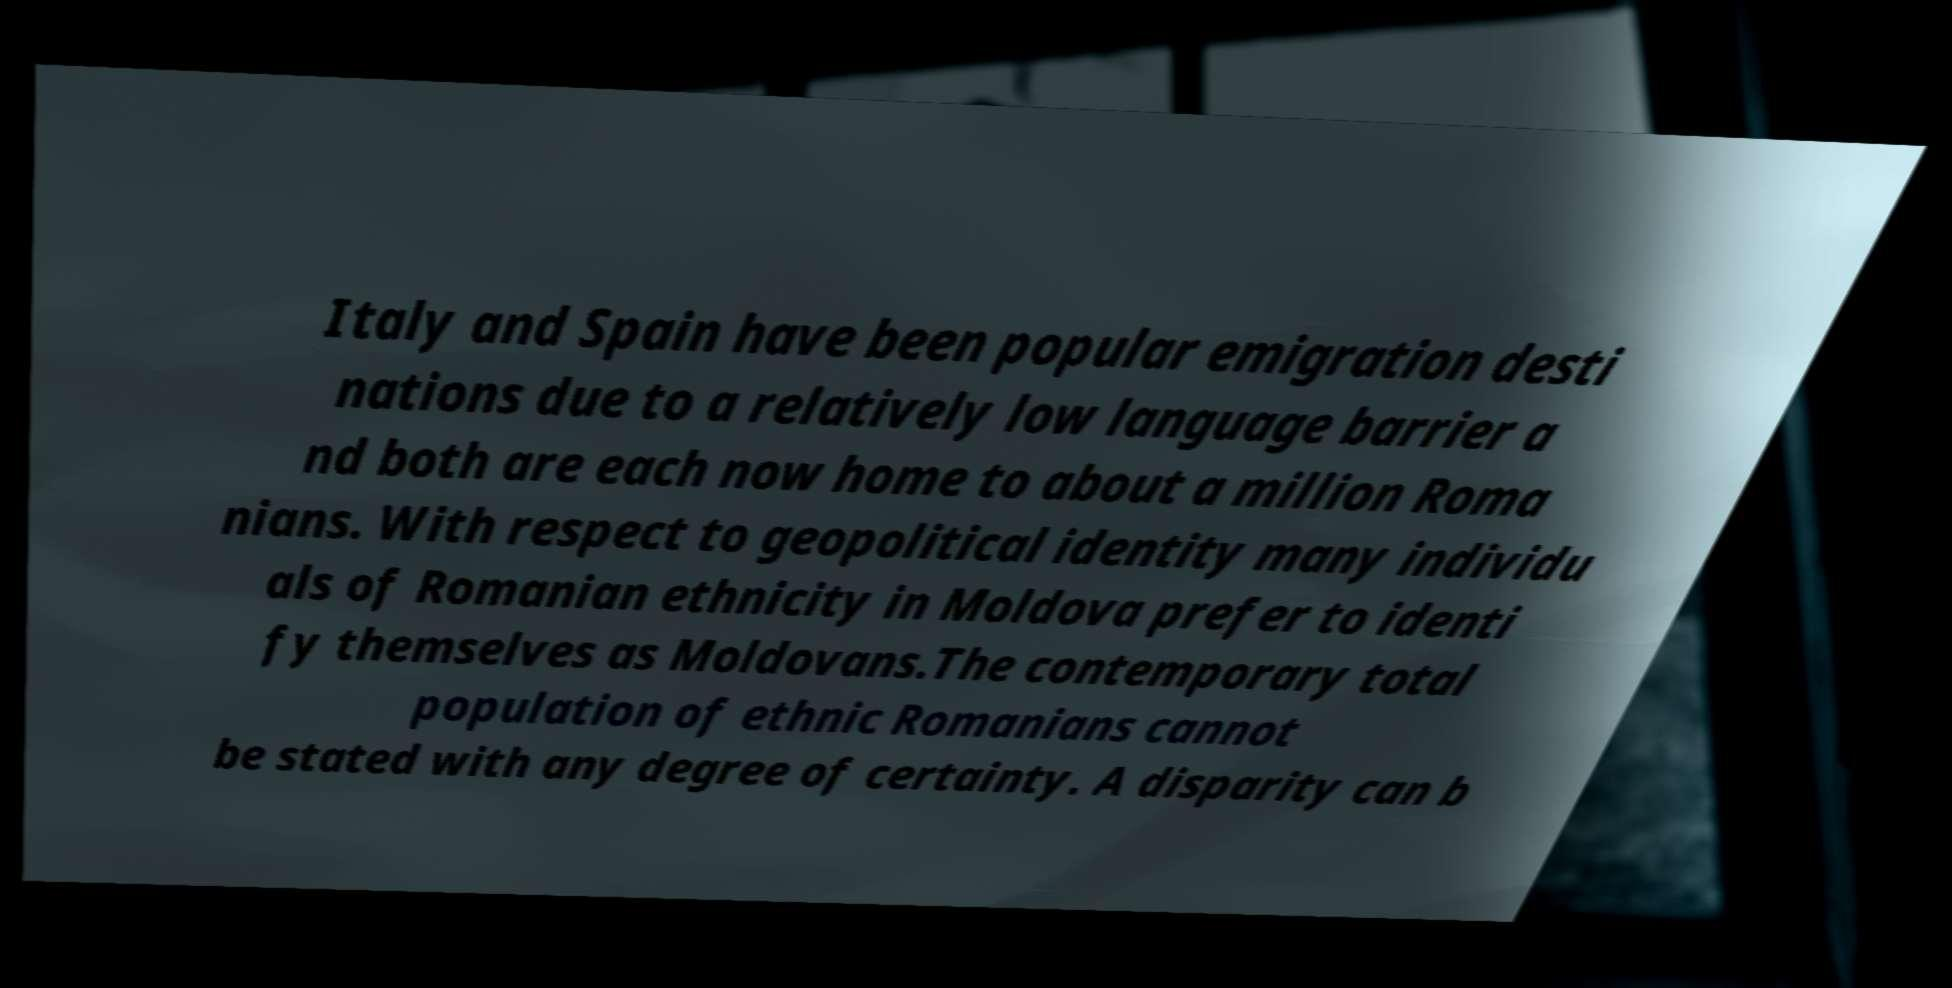Please read and relay the text visible in this image. What does it say? Italy and Spain have been popular emigration desti nations due to a relatively low language barrier a nd both are each now home to about a million Roma nians. With respect to geopolitical identity many individu als of Romanian ethnicity in Moldova prefer to identi fy themselves as Moldovans.The contemporary total population of ethnic Romanians cannot be stated with any degree of certainty. A disparity can b 